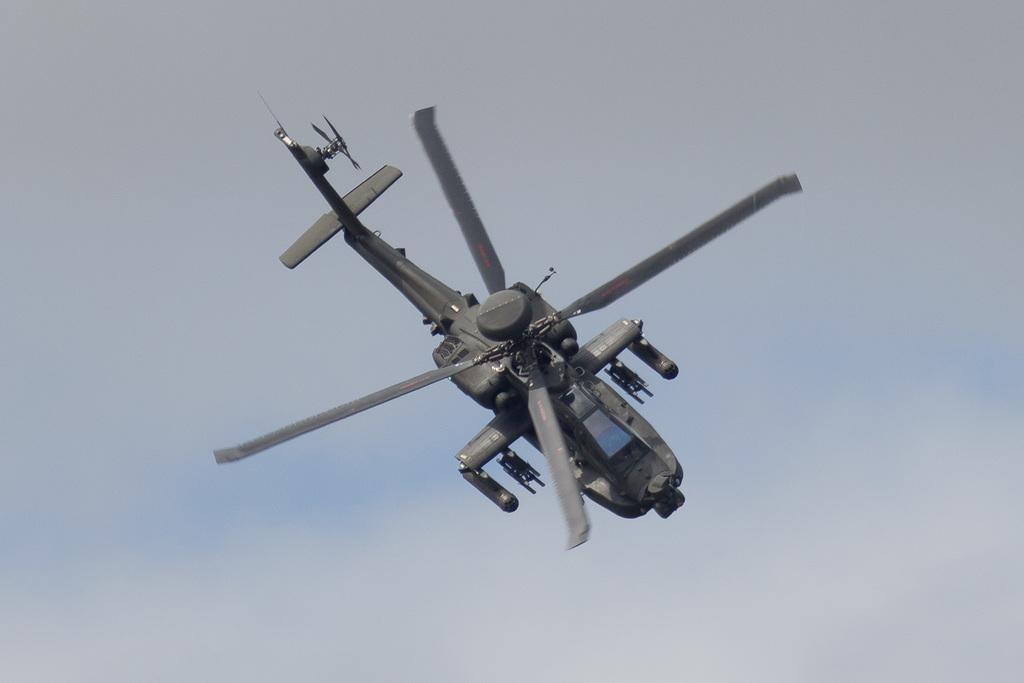What is the main subject of the image? The main subject of the image is a helicopter. What is the helicopter doing in the image? The helicopter is flying in the sky. What type of vacation is the helicopter planning for the market in the image? There is no mention of a vacation or market in the image; it simply shows a helicopter flying in the sky. 